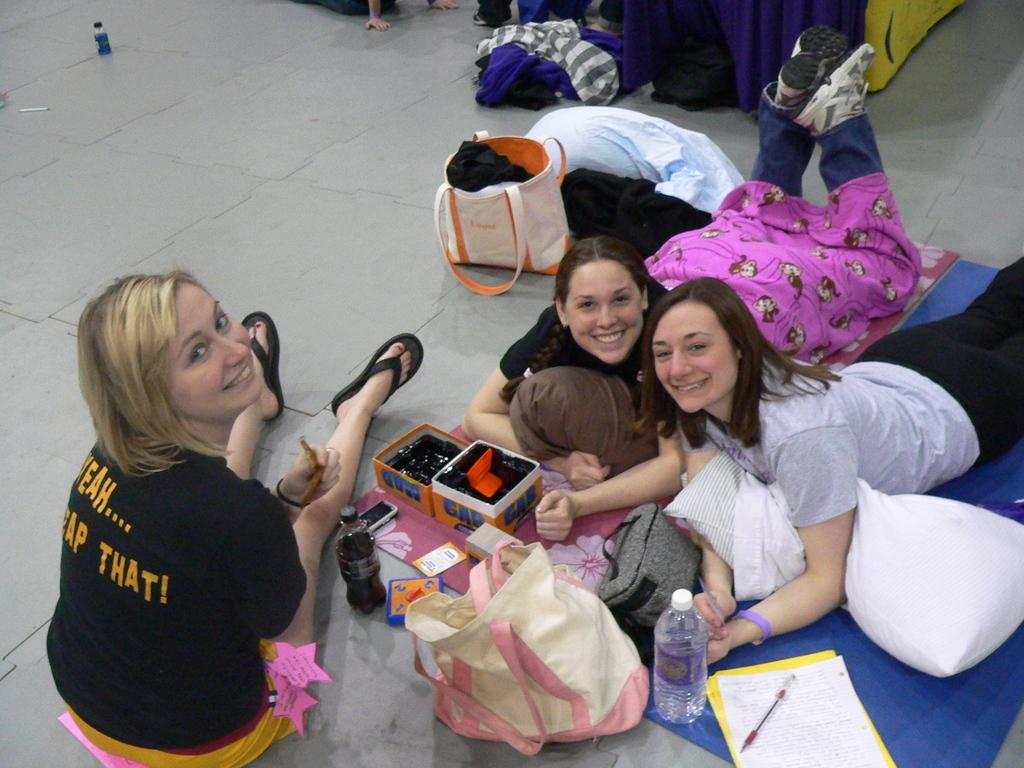Provide a one-sentence caption for the provided image. A lady sitting on the floor wearing a shirt with the word "that!" on the back. 